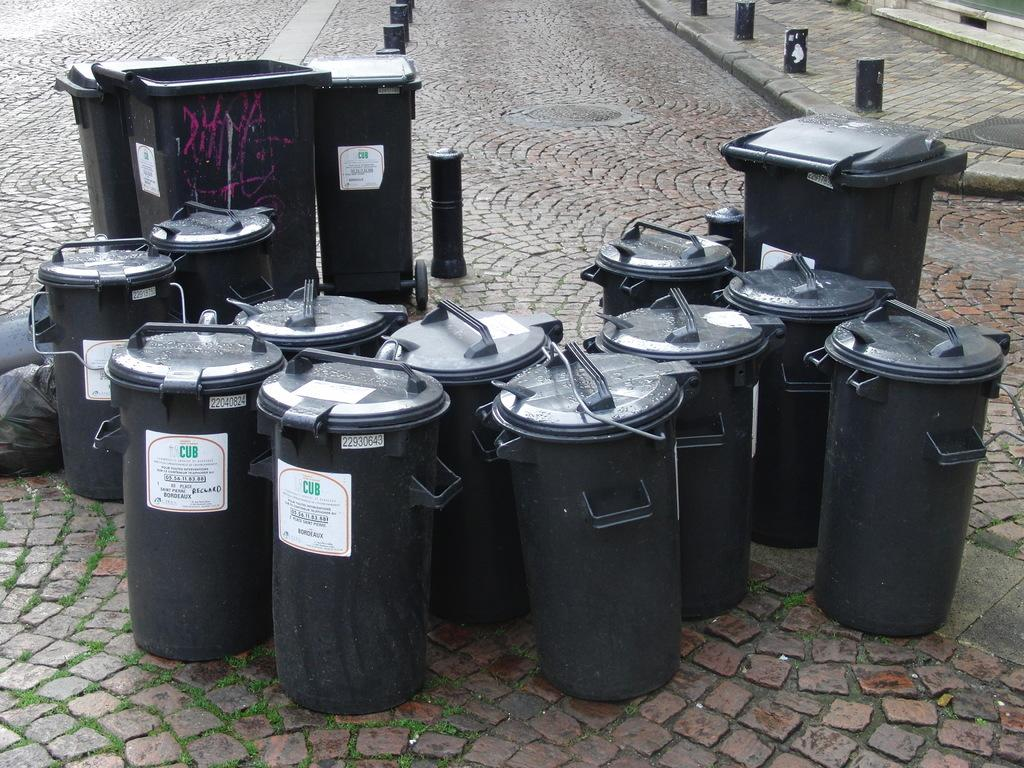Provide a one-sentence caption for the provided image. Smaller and Larger Black Garbage bins gathered on a street. 